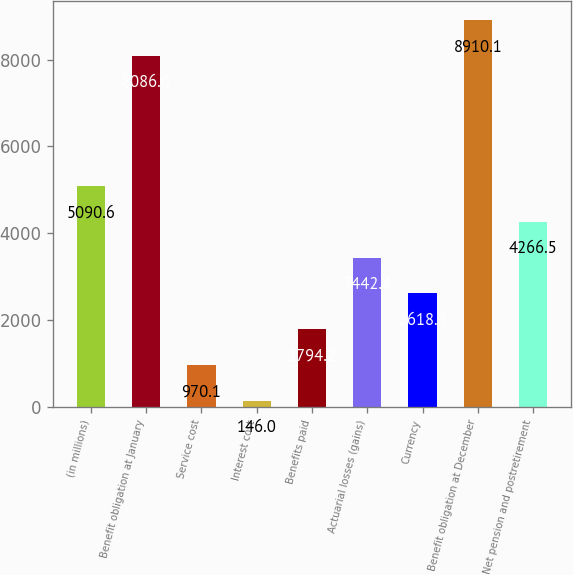<chart> <loc_0><loc_0><loc_500><loc_500><bar_chart><fcel>(in millions)<fcel>Benefit obligation at January<fcel>Service cost<fcel>Interest cost<fcel>Benefits paid<fcel>Actuarial losses (gains)<fcel>Currency<fcel>Benefit obligation at December<fcel>Net pension and postretirement<nl><fcel>5090.6<fcel>8086<fcel>970.1<fcel>146<fcel>1794.2<fcel>3442.4<fcel>2618.3<fcel>8910.1<fcel>4266.5<nl></chart> 